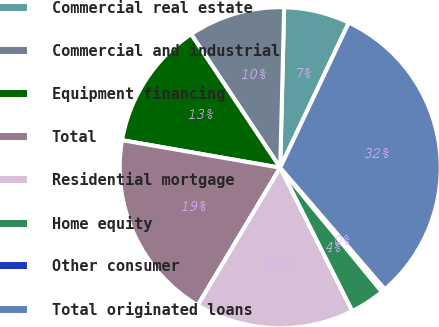Convert chart to OTSL. <chart><loc_0><loc_0><loc_500><loc_500><pie_chart><fcel>Commercial real estate<fcel>Commercial and industrial<fcel>Equipment financing<fcel>Total<fcel>Residential mortgage<fcel>Home equity<fcel>Other consumer<fcel>Total originated loans<nl><fcel>6.64%<fcel>9.76%<fcel>12.89%<fcel>19.15%<fcel>16.02%<fcel>3.51%<fcel>0.38%<fcel>31.66%<nl></chart> 